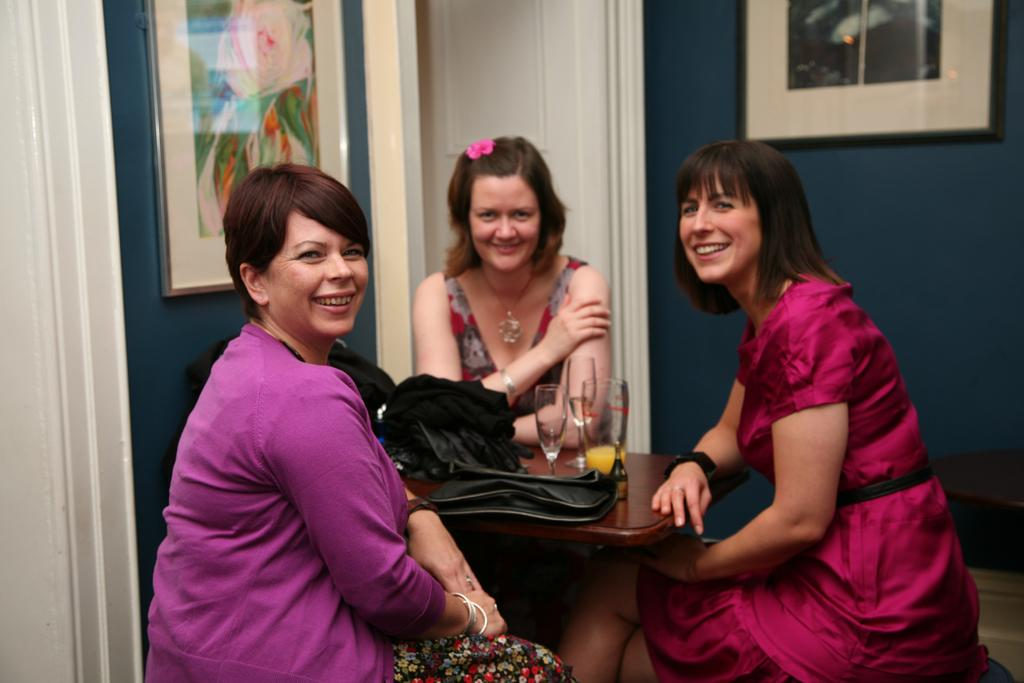What type of structure can be seen in the image? There is a wall in the image. Is there an entrance visible in the image? Yes, there is a door in the image. What can be seen hanging on the wall? There are photo frames in the image. How many people are sitting in the image? There are three people sitting on chairs in the image. What furniture is present in the image? There is a table in the image. What objects are on the table? There are glasses on the table. What type of digestion process is happening in the image? There is no digestion process visible in the image. Is there a hole in the wall in the image? No, there is no hole in the wall in the image. 